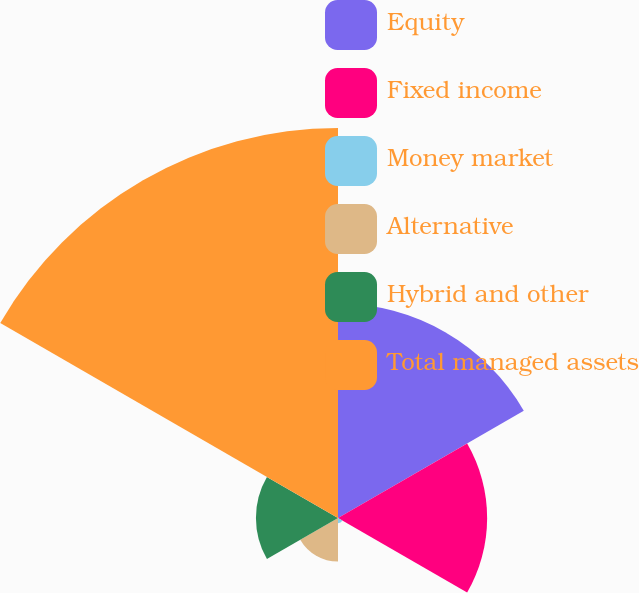Convert chart to OTSL. <chart><loc_0><loc_0><loc_500><loc_500><pie_chart><fcel>Equity<fcel>Fixed income<fcel>Money market<fcel>Alternative<fcel>Hybrid and other<fcel>Total managed assets<nl><fcel>24.25%<fcel>16.86%<fcel>0.58%<fcel>4.93%<fcel>9.28%<fcel>44.09%<nl></chart> 